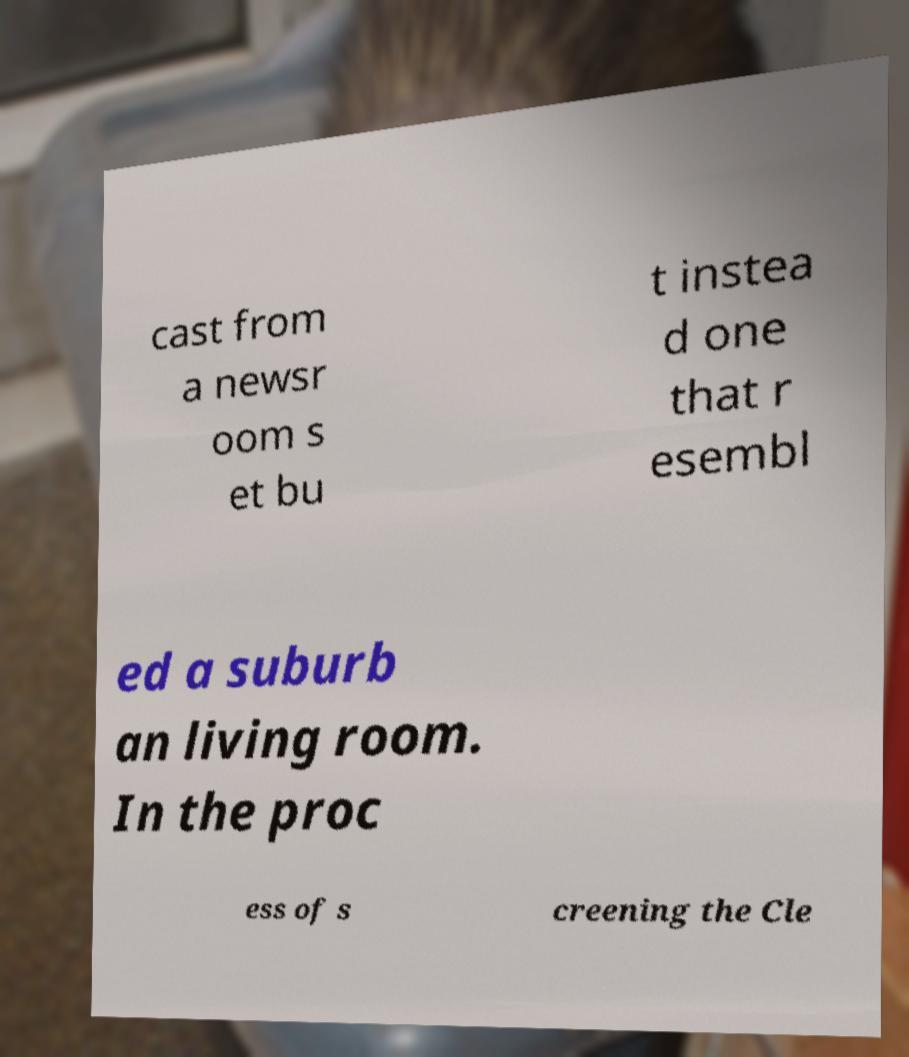For documentation purposes, I need the text within this image transcribed. Could you provide that? cast from a newsr oom s et bu t instea d one that r esembl ed a suburb an living room. In the proc ess of s creening the Cle 